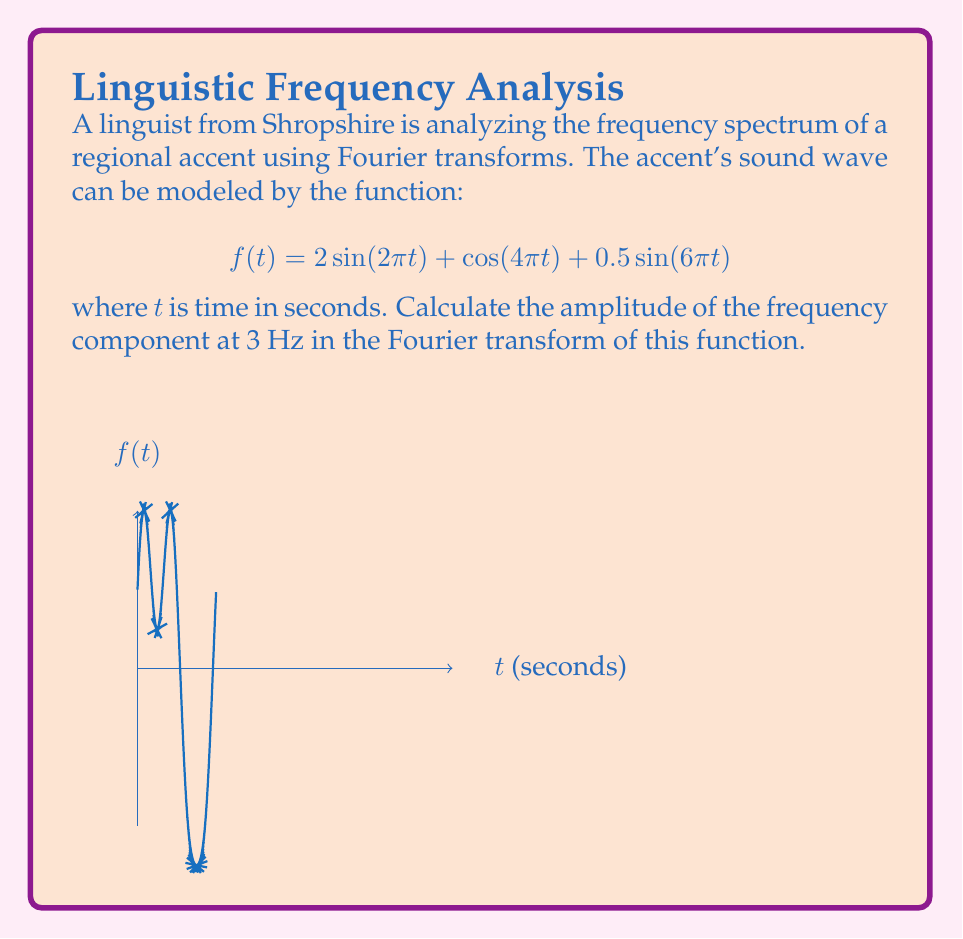Help me with this question. Let's approach this step-by-step:

1) The Fourier transform of a periodic function results in a series of impulses at the frequencies present in the function. 

2) Our function $f(t)$ is composed of three sinusoidal components:
   - $2\sin(2\pi t)$ with frequency 1 Hz
   - $\cos(4\pi t)$ with frequency 2 Hz
   - $0.5\sin(6\pi t)$ with frequency 3 Hz

3) The general form of a sinusoidal component is $A\sin(2\pi ft + \phi)$ or $A\cos(2\pi ft + \phi)$, where $A$ is the amplitude, $f$ is the frequency, and $\phi$ is the phase.

4) For the 3 Hz component, we have $0.5\sin(6\pi t)$, which matches the form $A\sin(2\pi ft)$ with $A = 0.5$ and $f = 3$.

5) In the Fourier transform, this component will appear as an impulse at 3 Hz with magnitude equal to half the amplitude of the time-domain signal (due to the properties of the Fourier transform).

6) Therefore, the amplitude of the 3 Hz component in the frequency domain will be $0.5 / 2 = 0.25$.
Answer: $0.25$ 